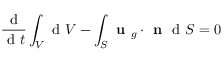<formula> <loc_0><loc_0><loc_500><loc_500>\frac { d } { d t } \int _ { V } d V - \int _ { S } u _ { g } \cdot n d S = 0</formula> 